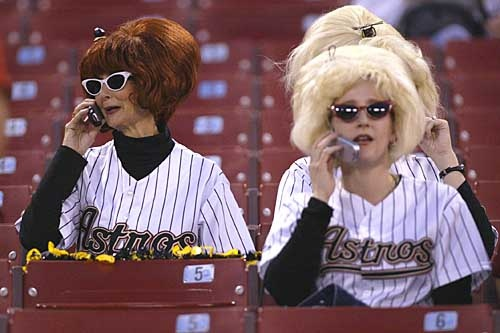Describe the objects in this image and their specific colors. I can see people in brown, lavender, black, darkgray, and gray tones, chair in brown, maroon, and lavender tones, chair in brown, maroon, and darkgray tones, chair in brown, maroon, and darkgray tones, and chair in brown tones in this image. 